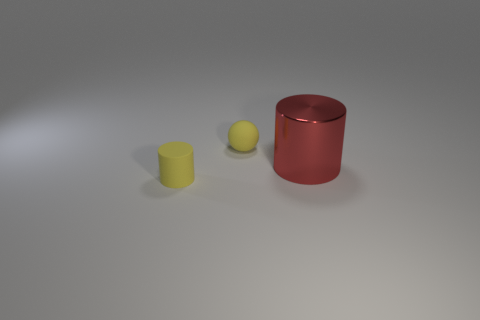What shape is the object that is the same color as the rubber sphere?
Offer a terse response. Cylinder. The large object has what color?
Your answer should be very brief. Red. There is a tiny matte thing to the left of the yellow ball; is it the same shape as the red thing?
Offer a very short reply. Yes. What number of objects are either matte cylinders that are in front of the sphere or blue metallic blocks?
Provide a succinct answer. 1. Is there a purple rubber object of the same shape as the red metallic thing?
Offer a terse response. No. There is a rubber object that is the same size as the sphere; what shape is it?
Ensure brevity in your answer.  Cylinder. There is a red object in front of the tiny yellow matte thing to the right of the yellow object that is in front of the red thing; what shape is it?
Your answer should be compact. Cylinder. Is the shape of the big thing the same as the small thing on the right side of the yellow matte cylinder?
Provide a succinct answer. No. What number of large things are either cyan metal things or matte objects?
Your response must be concise. 0. Is there a metallic cylinder of the same size as the yellow rubber cylinder?
Give a very brief answer. No. 